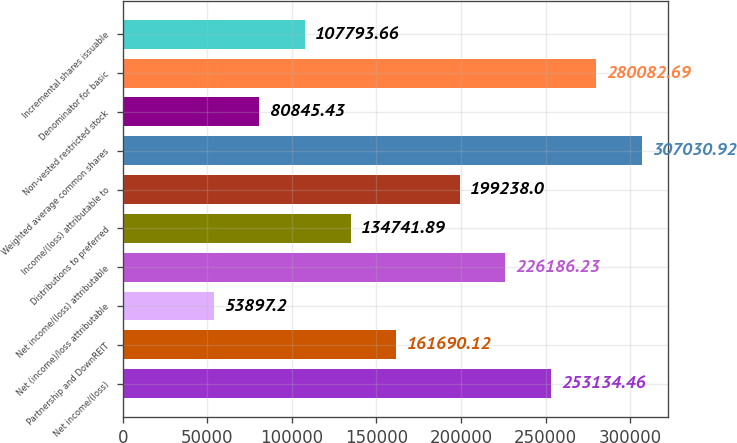Convert chart. <chart><loc_0><loc_0><loc_500><loc_500><bar_chart><fcel>Net income/(loss)<fcel>Partnership and DownREIT<fcel>Net (income)/loss attributable<fcel>Net income/(loss) attributable<fcel>Distributions to preferred<fcel>Income/(loss) attributable to<fcel>Weighted average common shares<fcel>Non-vested restricted stock<fcel>Denominator for basic<fcel>Incremental shares issuable<nl><fcel>253134<fcel>161690<fcel>53897.2<fcel>226186<fcel>134742<fcel>199238<fcel>307031<fcel>80845.4<fcel>280083<fcel>107794<nl></chart> 